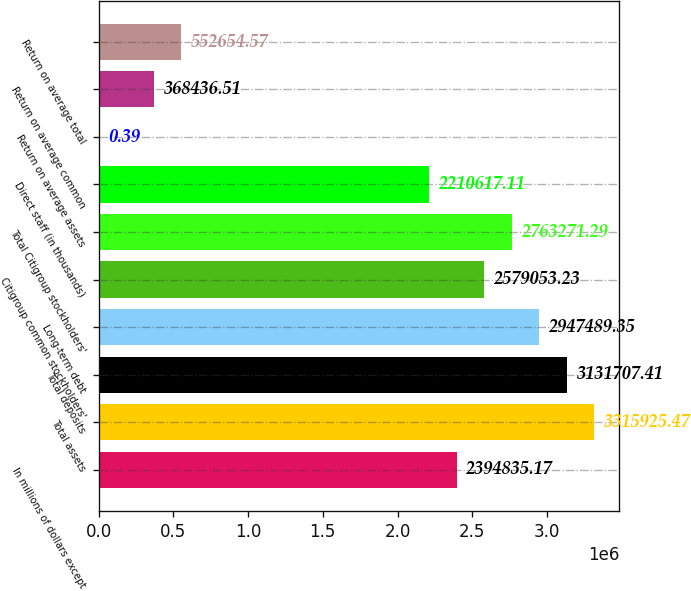Convert chart to OTSL. <chart><loc_0><loc_0><loc_500><loc_500><bar_chart><fcel>In millions of dollars except<fcel>Total assets<fcel>Total deposits<fcel>Long-term debt<fcel>Citigroup common stockholders'<fcel>Total Citigroup stockholders'<fcel>Direct staff (in thousands)<fcel>Return on average assets<fcel>Return on average common<fcel>Return on average total<nl><fcel>2.39484e+06<fcel>3.31593e+06<fcel>3.13171e+06<fcel>2.94749e+06<fcel>2.57905e+06<fcel>2.76327e+06<fcel>2.21062e+06<fcel>0.39<fcel>368437<fcel>552655<nl></chart> 